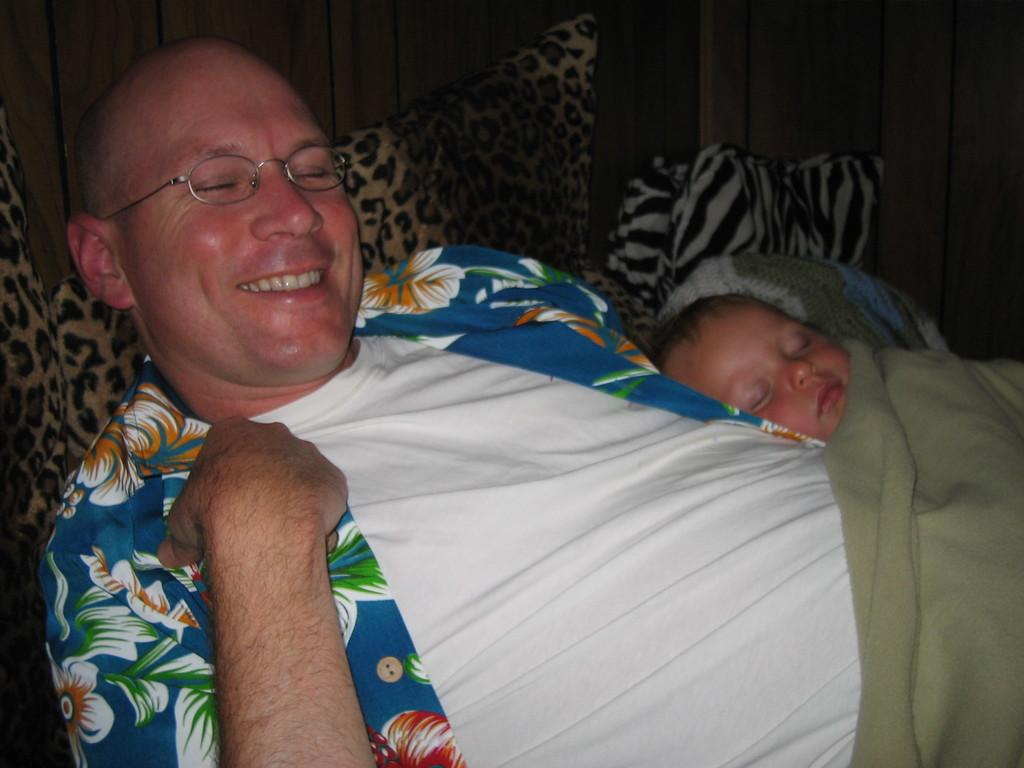Who is present in the image? There is a person and a baby in the image. What are the person and the baby doing in the image? Both the person and the baby are sleeping. What type of blanket can be seen in the image? There is a green color blanket in the image. What type of furniture is present in the image? There are pillows in the image. What material is the wall made of in the image? There is a wooden wall in the image. What type of discussion is taking place in the image? There is no discussion taking place in the image; both the person and the baby are sleeping. Can you see any goldfish in the image? There are no goldfish present in the image. 